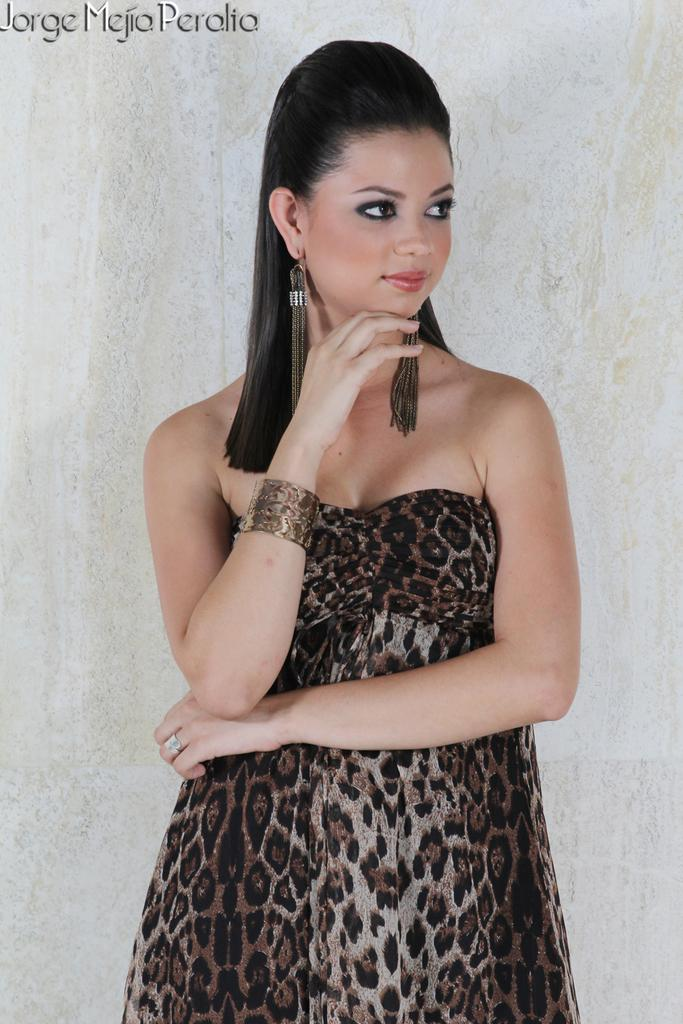What is the woman in the image doing? The woman is standing in the image and smiling. What can be seen in the background of the image? There is a wall in the background of the image. Is there any text or logo visible in the image? Yes, there is a watermark in the top left corner of the image. How many apples can be seen on the woman's teeth in the image? There are no apples or teeth visible in the image; it features a woman standing and smiling. What type of twig is the woman holding in the image? There is no twig present in the image. 